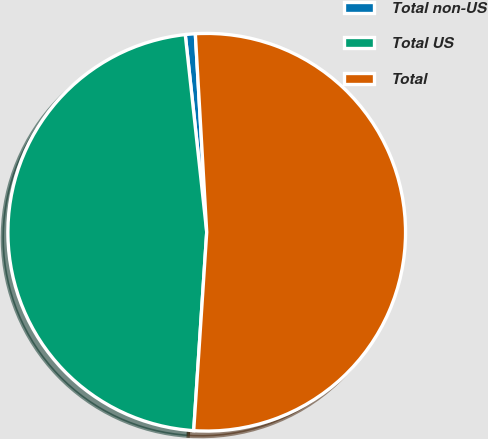Convert chart. <chart><loc_0><loc_0><loc_500><loc_500><pie_chart><fcel>Total non-US<fcel>Total US<fcel>Total<nl><fcel>0.81%<fcel>47.24%<fcel>51.96%<nl></chart> 